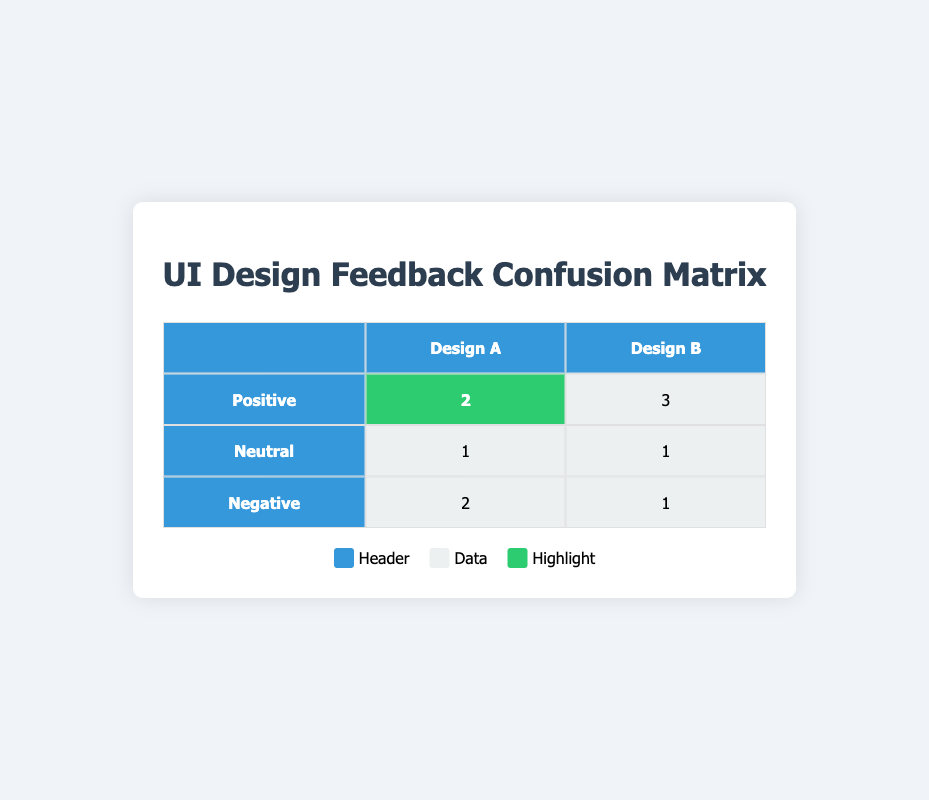What is the total number of positive feedbacks for Design A? In the confusion matrix, looking at the row for positive feedback under Design A, it shows there are 2 instances of positive feedback. Thus, the total number of positive feedbacks for Design A is directly stated in the table.
Answer: 2 How many users provided neutral feedback for Design B? The row for neutral feedback under Design B shows there is 1 instance of neutral feedback. Therefore, the total number of users who provided neutral feedback for Design B is directly taken from the table.
Answer: 1 What is the difference between the number of positive feedbacks for Design B and Design A? The table shows 3 positive feedbacks for Design B and 2 for Design A. The difference is calculated as 3 (Design B) - 2 (Design A) = 1.
Answer: 1 Are there more users who gave negative feedback for Design A than Design B? The table indicates there are 2 instances of negative feedback for Design A and 1 for Design B. Since 2 is greater than 1, the answer is yes.
Answer: Yes What percentage of users provided negative feedback for Design A? To find the percentage, we take the number of negative feedbacks for Design A, which is 2, and divide by the total number of users who tested Design A (2 positive + 1 neutral + 2 negative = 5). Then we multiply by 100 for the percentage: (2/5) * 100 = 40%.
Answer: 40% Which design received more overall positive and neutral feedback combined? For Design A, the sum of positive and neutral feedback is 2 (positive) + 1 (neutral) = 3. For Design B, it’s 3 (positive) + 1 (neutral) = 4. Since 4 for Design B is greater than 3 for Design A, Design B received more combined positive and neutral feedback.
Answer: Design B How many total feedbacks were provided for each design? For Design A, the total feedbacks are 5 (2 positive + 1 neutral + 2 negative). For Design B, the total is 5 (3 positive + 1 neutral + 1 negative). Both designs received 5 feedbacks total.
Answer: 5 for both designs Is the positive feedback the highest rating for either design? Looking at the confusion matrix, positive feedback has the highest count for both designs since negative has 2 for A and 1 for B, while neutral has 1 for both. Therefore, positive feedback is the highest rating for both designs.
Answer: Yes What is the ratio of positive to negative feedback for Design A? Design A has 2 positive feedbacks and 2 negative feedbacks. The ratio is calculated as 2 (positive) to 2 (negative) which simplifies to 1:1.
Answer: 1:1 